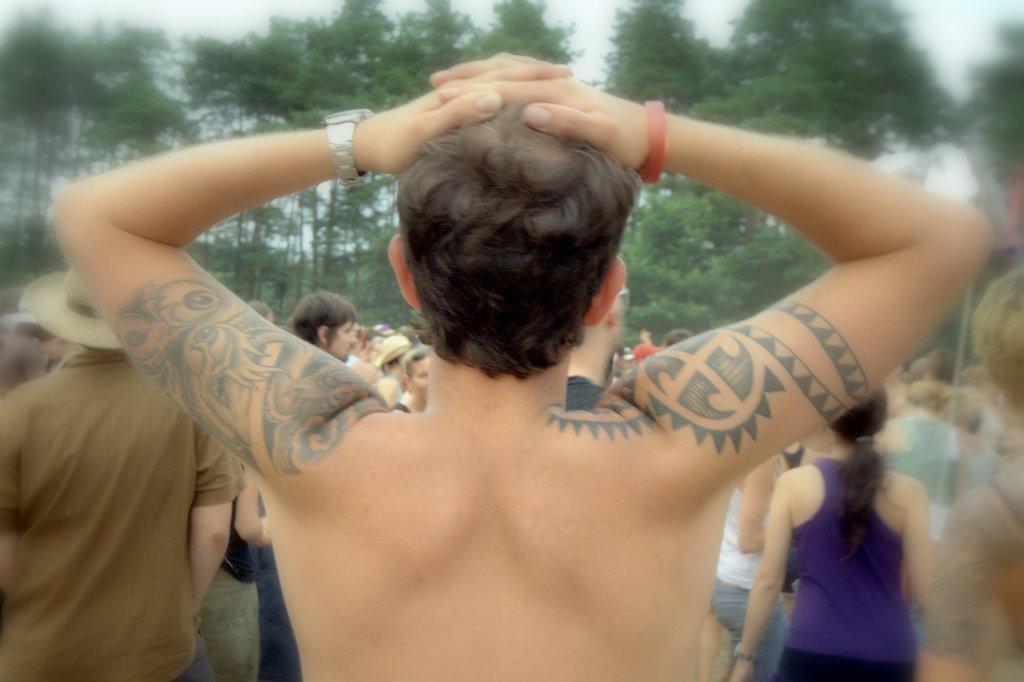Could you give a brief overview of what you see in this image? In this picture we can see a man is standing on the path and in front of the man there are groups of people, trees and a sky. 